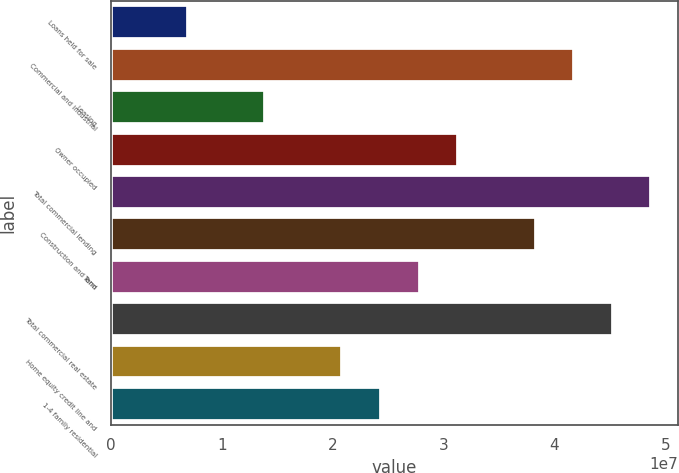<chart> <loc_0><loc_0><loc_500><loc_500><bar_chart><fcel>Loans held for sale<fcel>Commercial and industrial<fcel>Leasing<fcel>Owner occupied<fcel>Total commercial lending<fcel>Construction and land<fcel>Term<fcel>Total commercial real estate<fcel>Home equity credit line and<fcel>1-4 family residential<nl><fcel>6.96604e+06<fcel>4.17822e+07<fcel>1.39293e+07<fcel>3.13373e+07<fcel>4.87454e+07<fcel>3.83005e+07<fcel>2.78557e+07<fcel>4.52638e+07<fcel>2.08925e+07<fcel>2.43741e+07<nl></chart> 